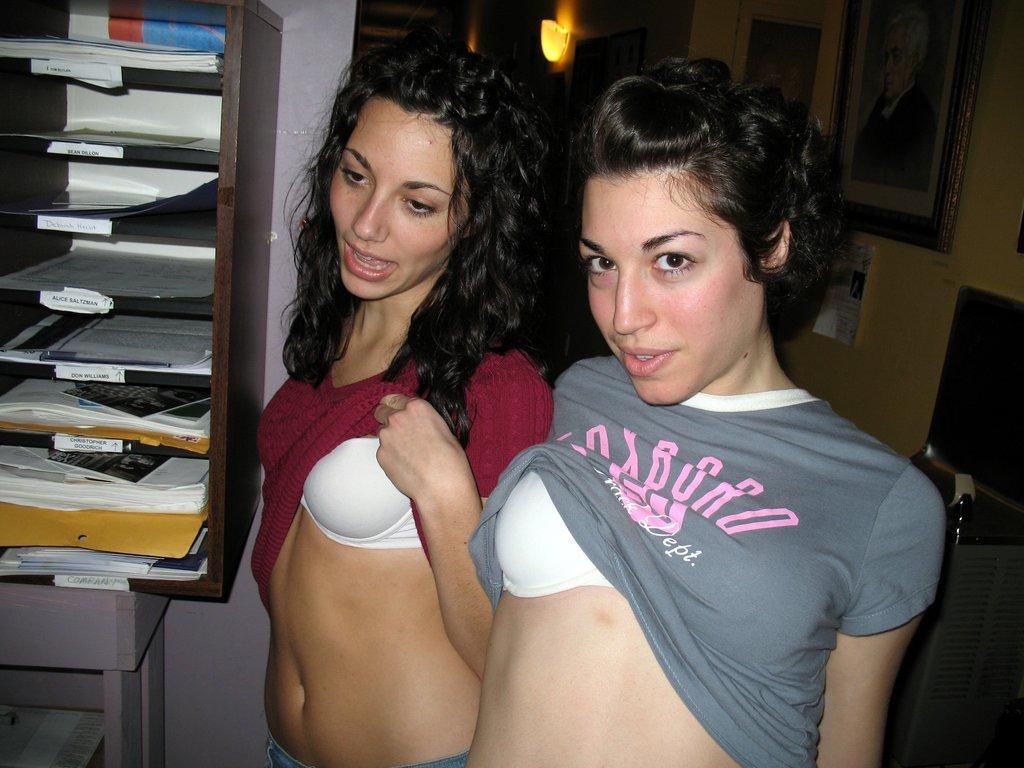<image>
Create a compact narrative representing the image presented. Two girls are lifting their shirts up and one of the shirts says Foxboro in pink letters. 